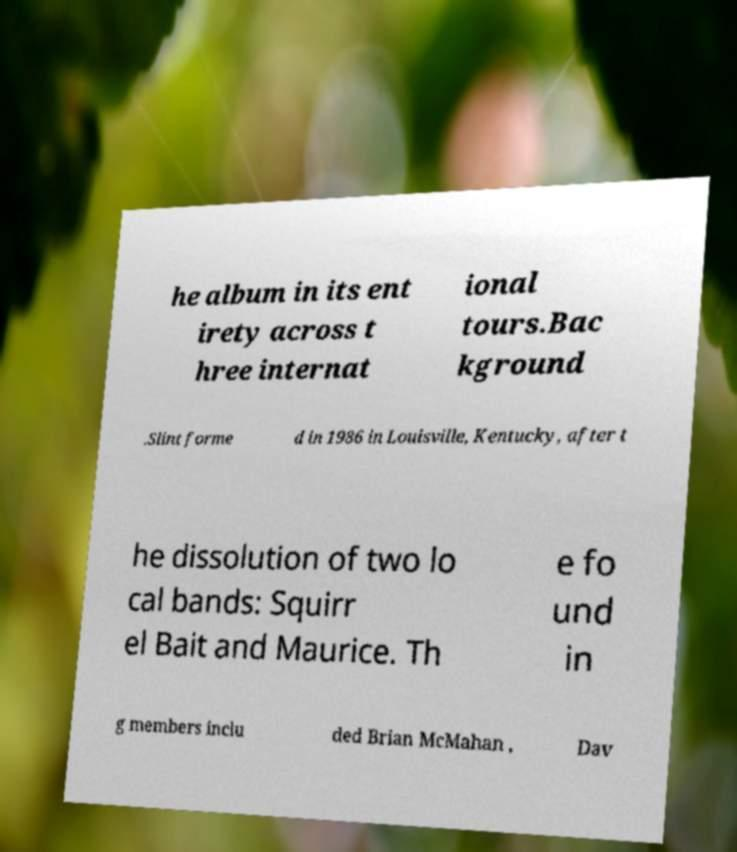Could you extract and type out the text from this image? he album in its ent irety across t hree internat ional tours.Bac kground .Slint forme d in 1986 in Louisville, Kentucky, after t he dissolution of two lo cal bands: Squirr el Bait and Maurice. Th e fo und in g members inclu ded Brian McMahan , Dav 